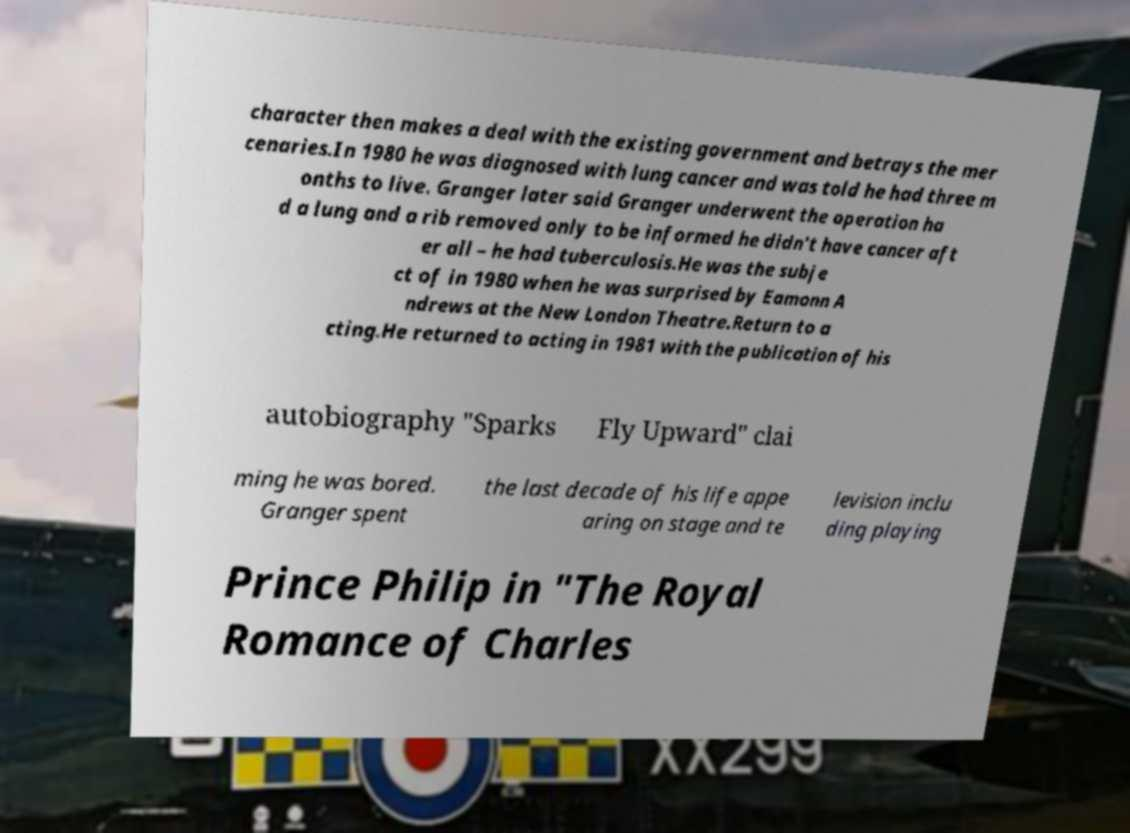There's text embedded in this image that I need extracted. Can you transcribe it verbatim? character then makes a deal with the existing government and betrays the mer cenaries.In 1980 he was diagnosed with lung cancer and was told he had three m onths to live. Granger later said Granger underwent the operation ha d a lung and a rib removed only to be informed he didn't have cancer aft er all – he had tuberculosis.He was the subje ct of in 1980 when he was surprised by Eamonn A ndrews at the New London Theatre.Return to a cting.He returned to acting in 1981 with the publication of his autobiography "Sparks Fly Upward" clai ming he was bored. Granger spent the last decade of his life appe aring on stage and te levision inclu ding playing Prince Philip in "The Royal Romance of Charles 